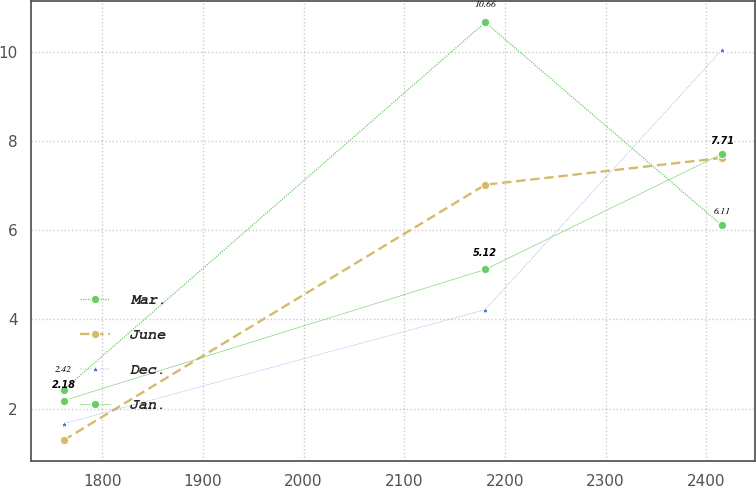<chart> <loc_0><loc_0><loc_500><loc_500><line_chart><ecel><fcel>Mar.<fcel>June<fcel>Dec.<fcel>Jan.<nl><fcel>1761.58<fcel>2.42<fcel>1.29<fcel>1.66<fcel>2.18<nl><fcel>2180.54<fcel>10.66<fcel>7.02<fcel>4.22<fcel>5.12<nl><fcel>2415.53<fcel>6.11<fcel>7.62<fcel>10.04<fcel>7.71<nl></chart> 